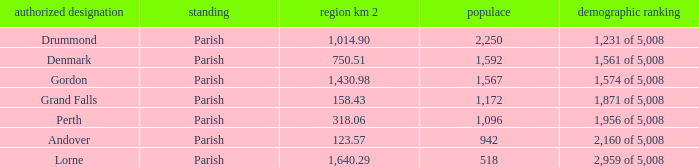Which parish has an area of 750.51? Denmark. 